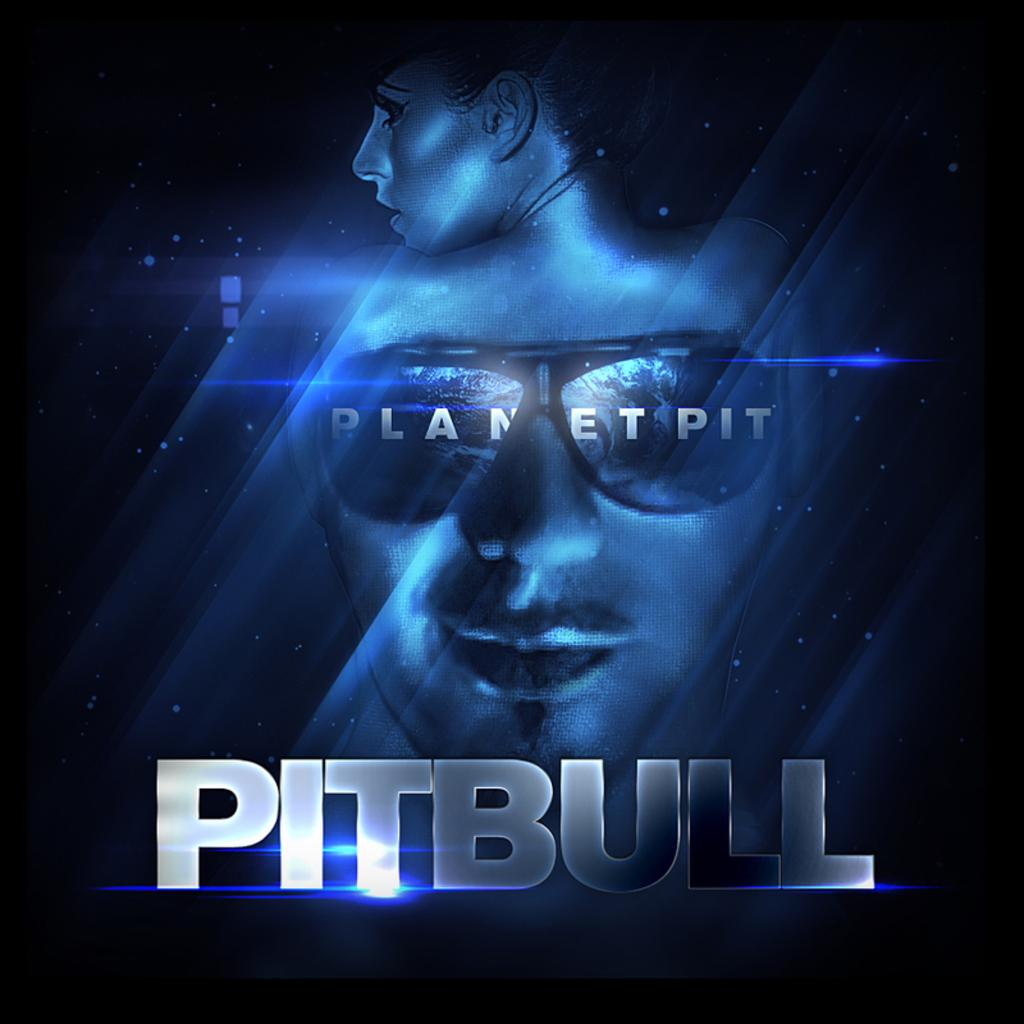Who is present in the image? There is a woman and a man with glasses in the image. Can you describe any specific features of the man? The man is wearing glasses. What additional information can be gathered from the image? There are names present in the image. What type of rose can be seen on the chairs in the image? There are no roses or chairs present in the image. How is the rice being served in the image? There is no rice present in the image. 